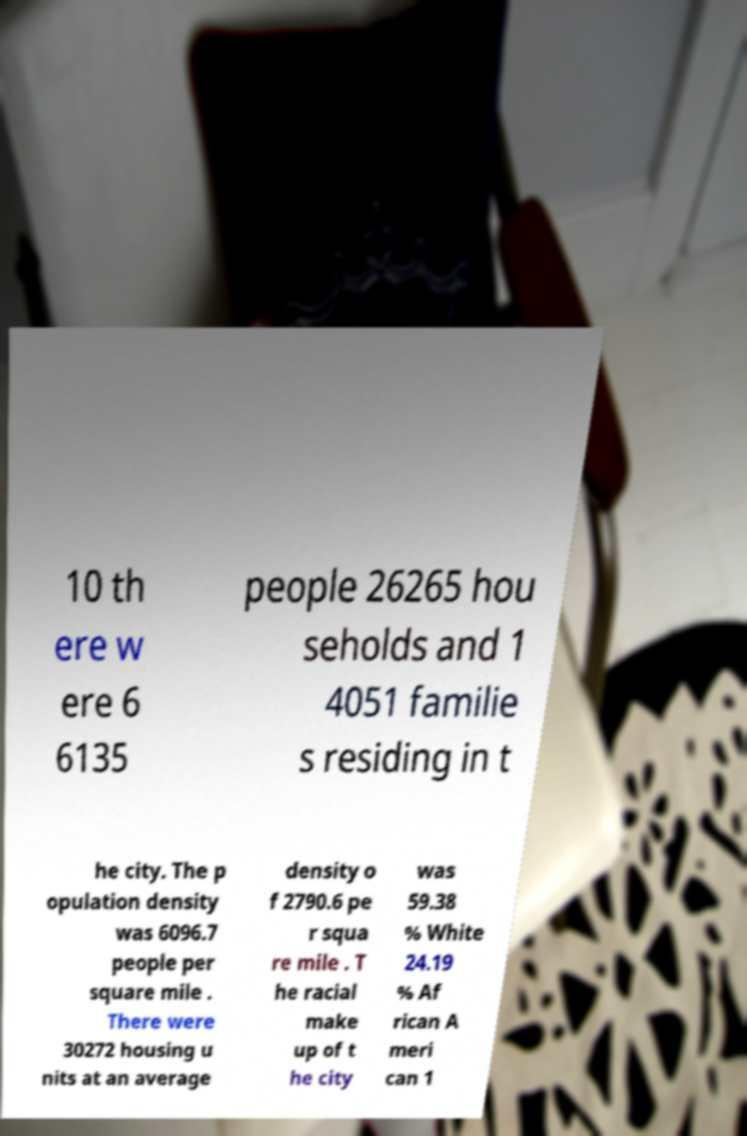Could you extract and type out the text from this image? 10 th ere w ere 6 6135 people 26265 hou seholds and 1 4051 familie s residing in t he city. The p opulation density was 6096.7 people per square mile . There were 30272 housing u nits at an average density o f 2790.6 pe r squa re mile . T he racial make up of t he city was 59.38 % White 24.19 % Af rican A meri can 1 